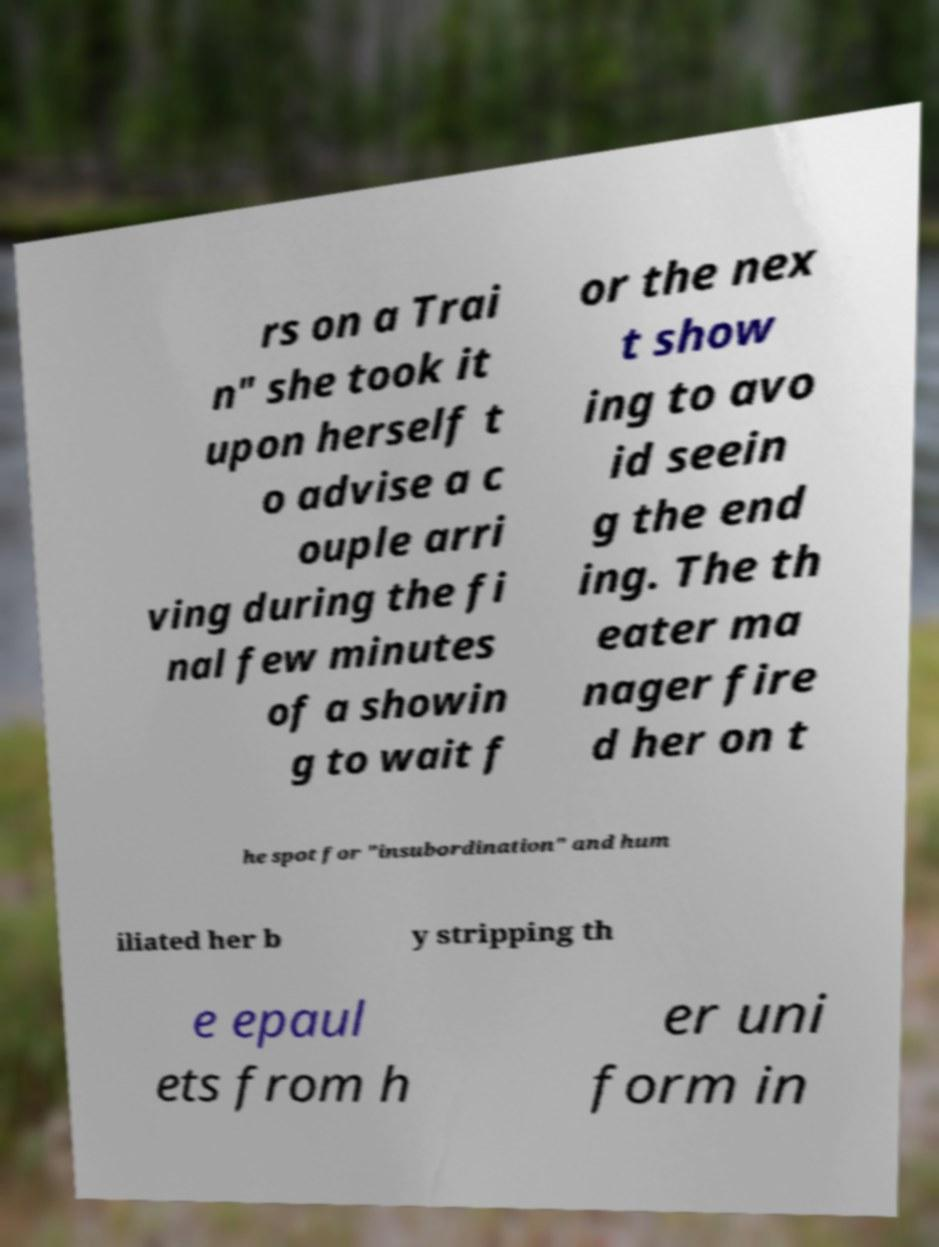Could you assist in decoding the text presented in this image and type it out clearly? rs on a Trai n" she took it upon herself t o advise a c ouple arri ving during the fi nal few minutes of a showin g to wait f or the nex t show ing to avo id seein g the end ing. The th eater ma nager fire d her on t he spot for "insubordination" and hum iliated her b y stripping th e epaul ets from h er uni form in 